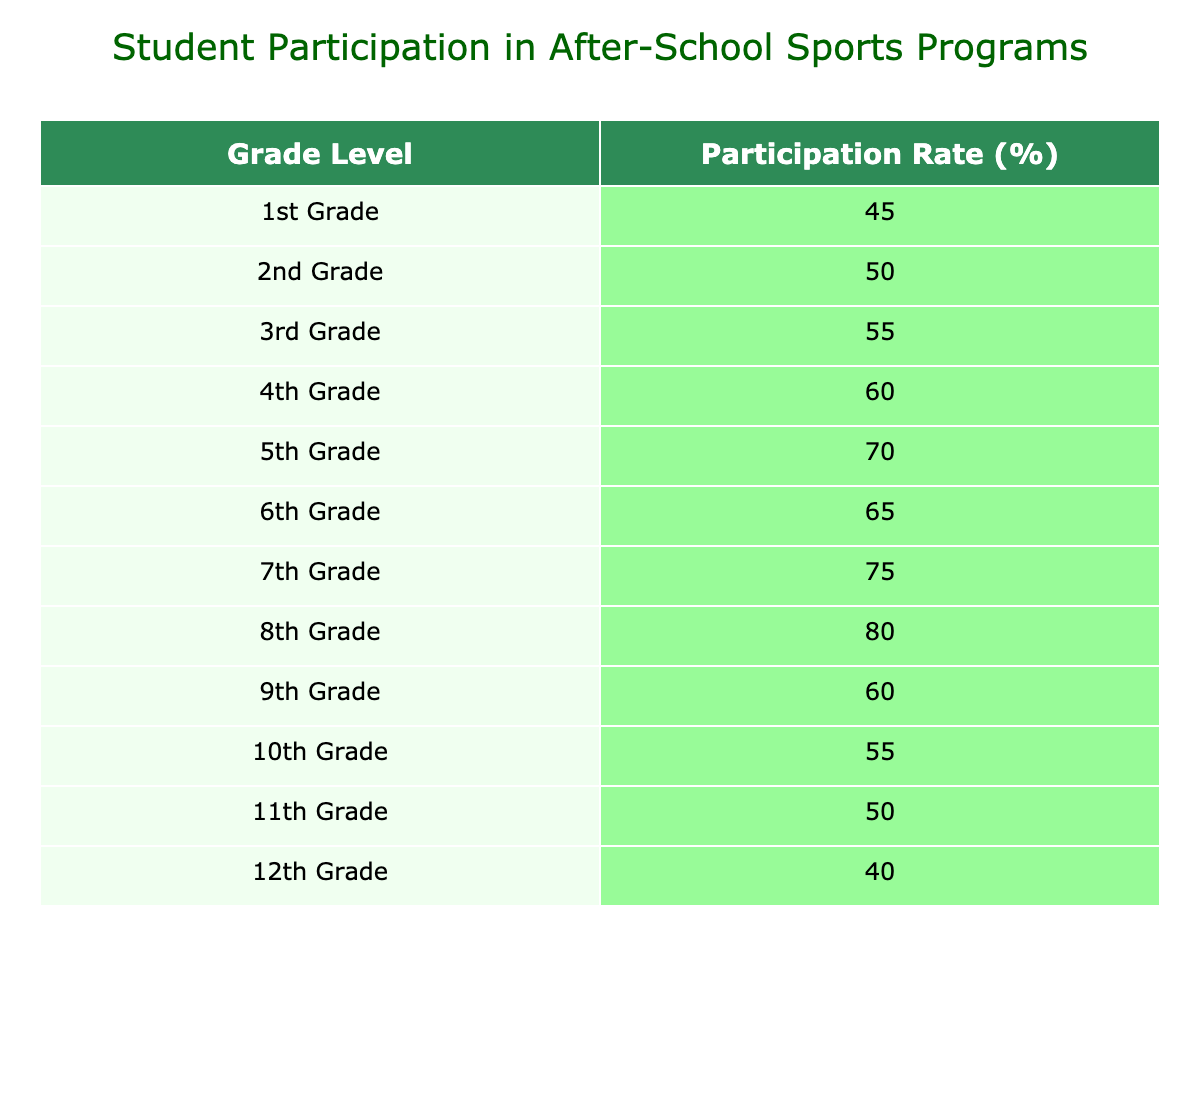What is the participation rate for 5th Grade? The table shows the participation rates per grade level. Looking under the 5th Grade row, the participation rate listed is 70%.
Answer: 70% What is the average participation rate for high school grades (9th to 12th)? The participation rates for high school grades are 60%, 55%, 50%, and 40%. To find the average, we sum these values: 60 + 55 + 50 + 40 = 205. Then, we divide by the number of grades, which is 4. So, 205 / 4 = 51.25.
Answer: 51.25 Is the participation rate for 2nd Grade higher than that for 12th Grade? The participation rate for 2nd Grade is 50%, and for 12th Grade, it is 40%. Since 50 is greater than 40, the statement is true.
Answer: Yes Which grade level has the highest participation rate? By examining the table, the participation rates are compared across all grade levels. The highest rate is found under 8th Grade, which has a participation rate of 80%.
Answer: 8th Grade If we consider grades 6 to 8, what is their combined participation rate? The participation rates for 6th, 7th, and 8th grades are 65%, 75%, and 80% respectively. To find the combined participation rate, we sum these values: 65 + 75 + 80 = 220.
Answer: 220 